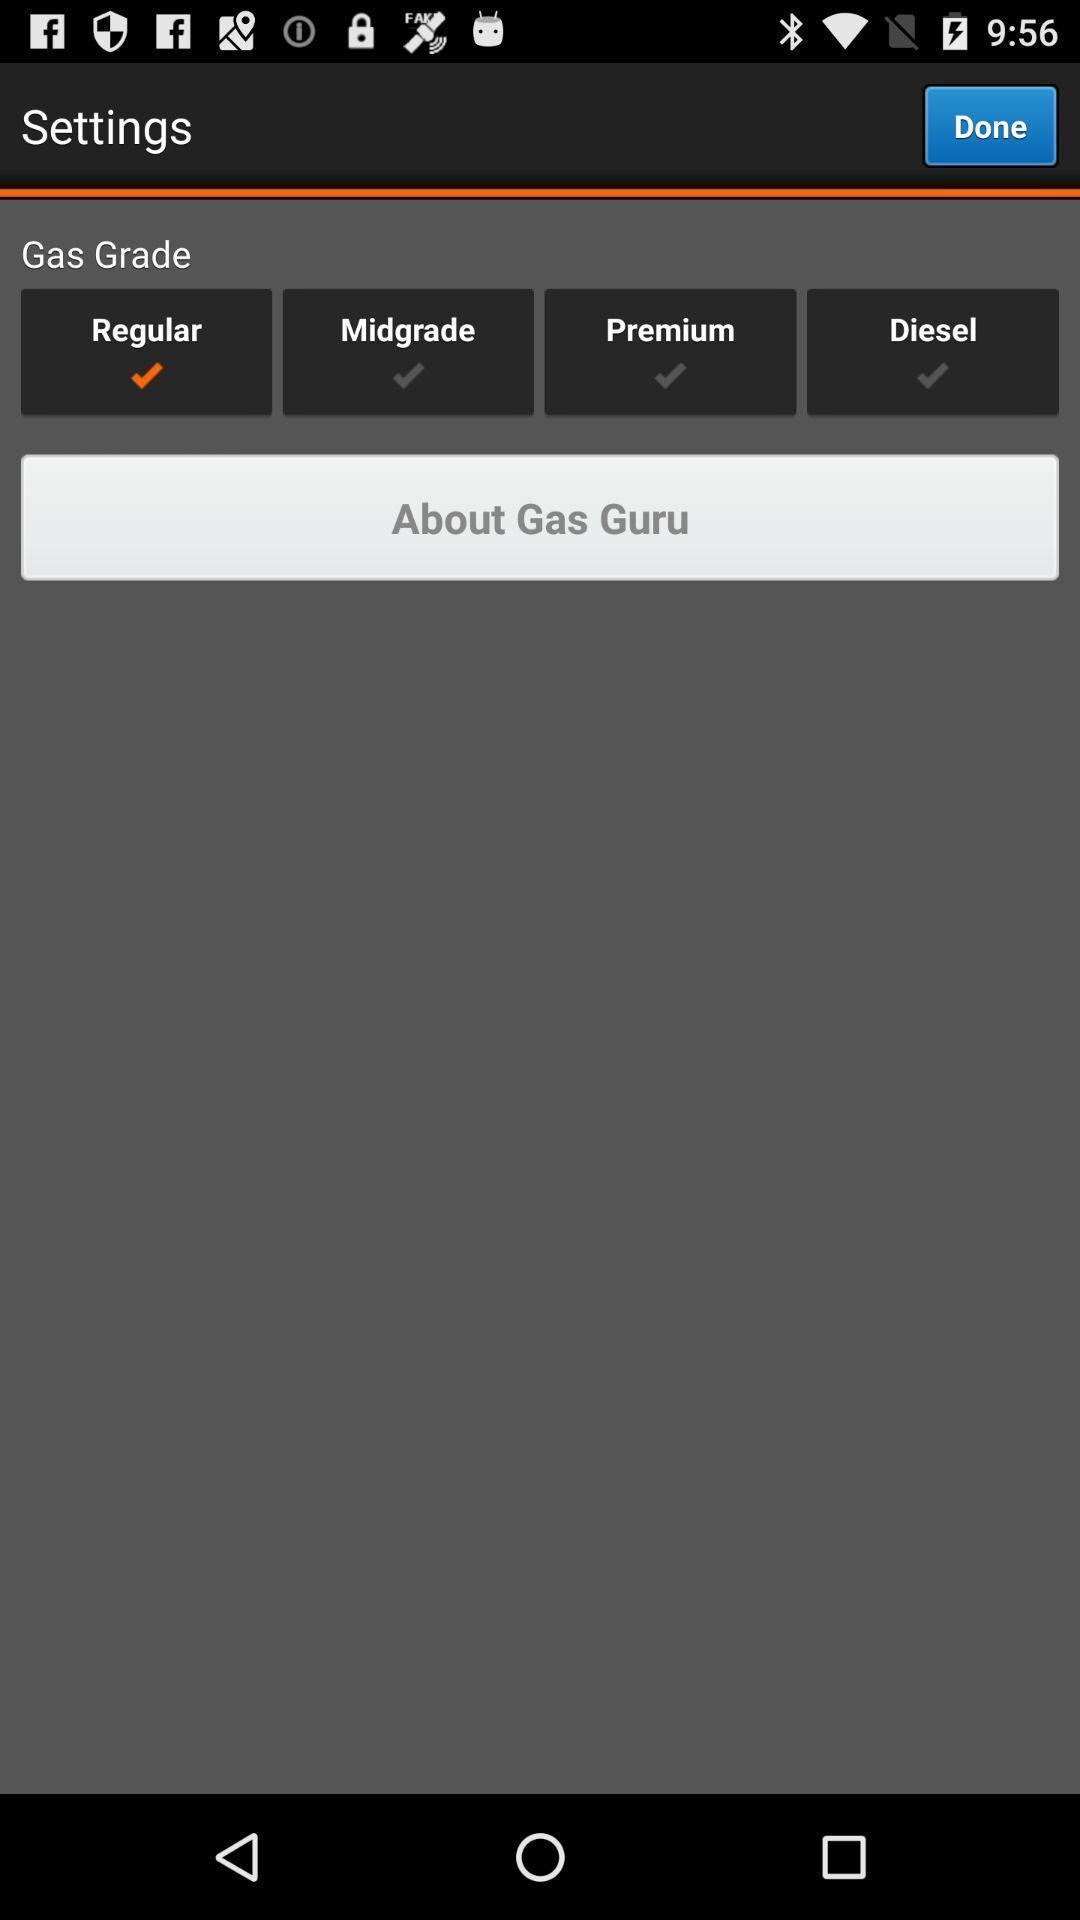Provide a description of this screenshot. Screen displaying multiple options in settings page. 